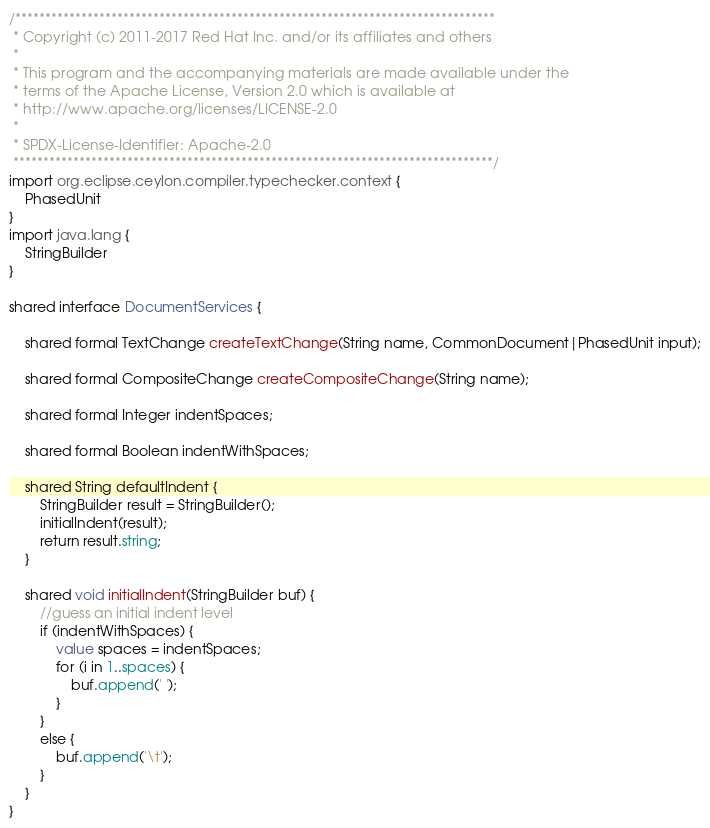<code> <loc_0><loc_0><loc_500><loc_500><_Ceylon_>/********************************************************************************
 * Copyright (c) 2011-2017 Red Hat Inc. and/or its affiliates and others
 *
 * This program and the accompanying materials are made available under the 
 * terms of the Apache License, Version 2.0 which is available at
 * http://www.apache.org/licenses/LICENSE-2.0
 *
 * SPDX-License-Identifier: Apache-2.0 
 ********************************************************************************/
import org.eclipse.ceylon.compiler.typechecker.context {
    PhasedUnit
}
import java.lang {
    StringBuilder
}

shared interface DocumentServices {

    shared formal TextChange createTextChange(String name, CommonDocument|PhasedUnit input);

    shared formal CompositeChange createCompositeChange(String name);

    shared formal Integer indentSpaces;

    shared formal Boolean indentWithSpaces;

    shared String defaultIndent {
        StringBuilder result = StringBuilder();
        initialIndent(result);
        return result.string;
    }

    shared void initialIndent(StringBuilder buf) {
        //guess an initial indent level
        if (indentWithSpaces) {
            value spaces = indentSpaces;
            for (i in 1..spaces) {
                buf.append(' ');
            }
        }
        else {
            buf.append('\t');
        }
    }
}</code> 